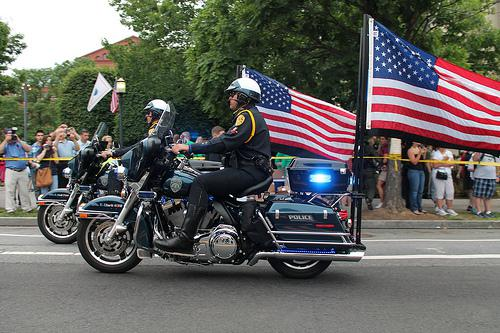Question: what color is the road?
Choices:
A. Black.
B. Gray.
C. Yellow.
D. White.
Answer with the letter. Answer: B Question: who are the people on motorcycles?
Choices:
A. Fireman.
B. Gang.
C. Police.
D. Ladies.
Answer with the letter. Answer: C Question: where is the crowd?
Choices:
A. Behind Rope.
B. In front of the arena.
C. In the arena.
D. Outside the arena.
Answer with the letter. Answer: A Question: what color are trees?
Choices:
A. Brown.
B. Yellow.
C. Green.
D. Black.
Answer with the letter. Answer: C Question: where are the motorcycles?
Choices:
A. On road.
B. On the street.
C. Across the street.
D. In the parking garage.
Answer with the letter. Answer: A Question: what color are motorcycles?
Choices:
A. White.
B. Black.
C. Blue.
D. Red.
Answer with the letter. Answer: B 